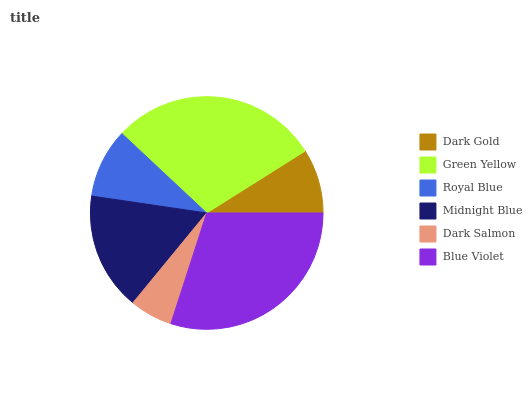Is Dark Salmon the minimum?
Answer yes or no. Yes. Is Blue Violet the maximum?
Answer yes or no. Yes. Is Green Yellow the minimum?
Answer yes or no. No. Is Green Yellow the maximum?
Answer yes or no. No. Is Green Yellow greater than Dark Gold?
Answer yes or no. Yes. Is Dark Gold less than Green Yellow?
Answer yes or no. Yes. Is Dark Gold greater than Green Yellow?
Answer yes or no. No. Is Green Yellow less than Dark Gold?
Answer yes or no. No. Is Midnight Blue the high median?
Answer yes or no. Yes. Is Royal Blue the low median?
Answer yes or no. Yes. Is Dark Salmon the high median?
Answer yes or no. No. Is Green Yellow the low median?
Answer yes or no. No. 